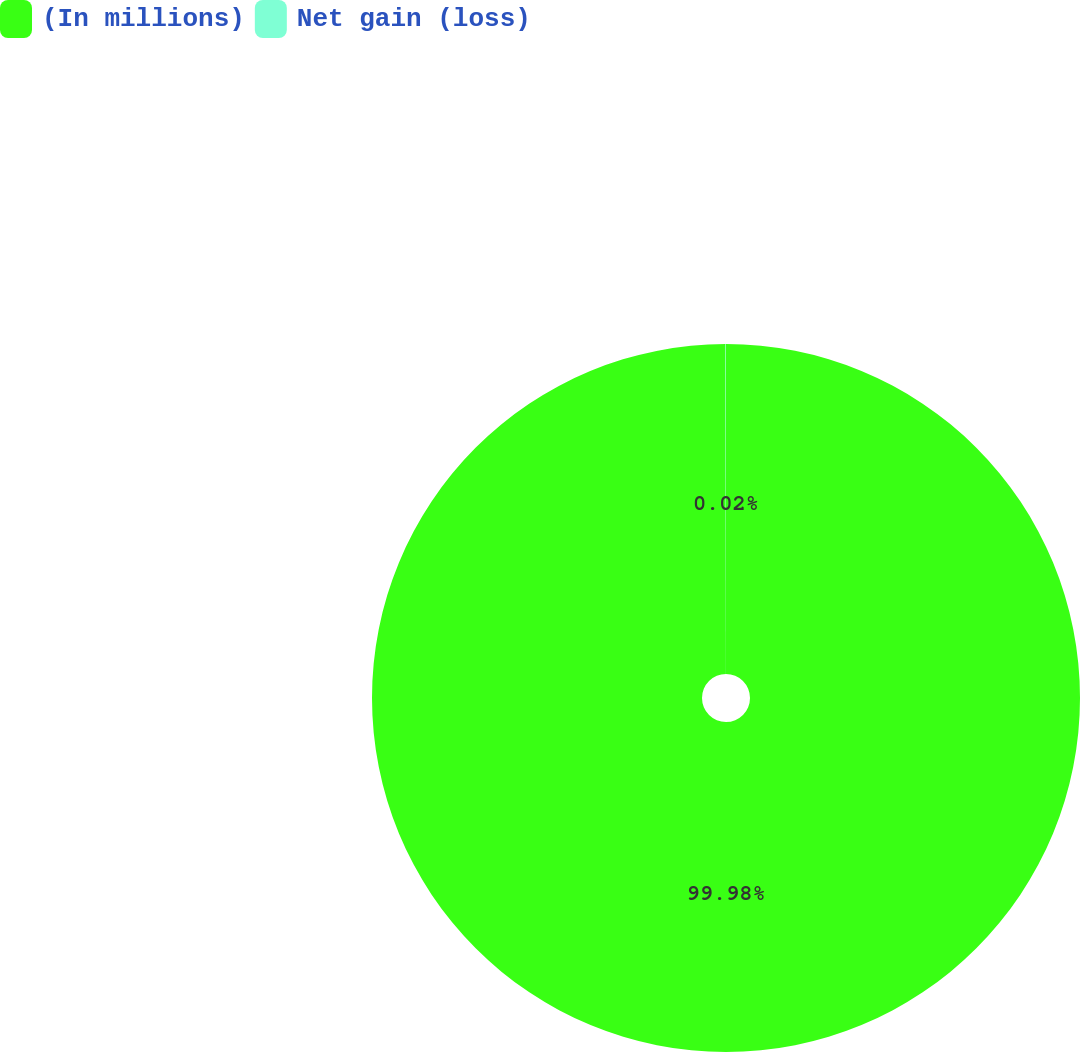Convert chart. <chart><loc_0><loc_0><loc_500><loc_500><pie_chart><fcel>(In millions)<fcel>Net gain (loss)<nl><fcel>99.98%<fcel>0.02%<nl></chart> 